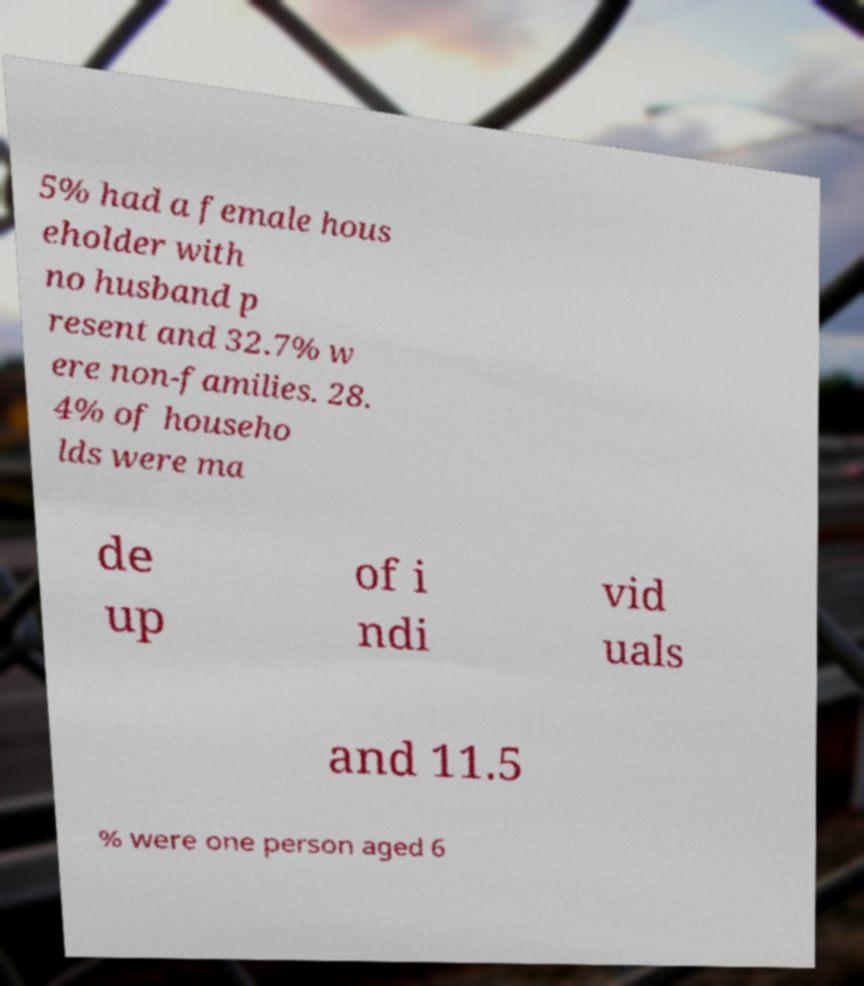Can you accurately transcribe the text from the provided image for me? 5% had a female hous eholder with no husband p resent and 32.7% w ere non-families. 28. 4% of househo lds were ma de up of i ndi vid uals and 11.5 % were one person aged 6 